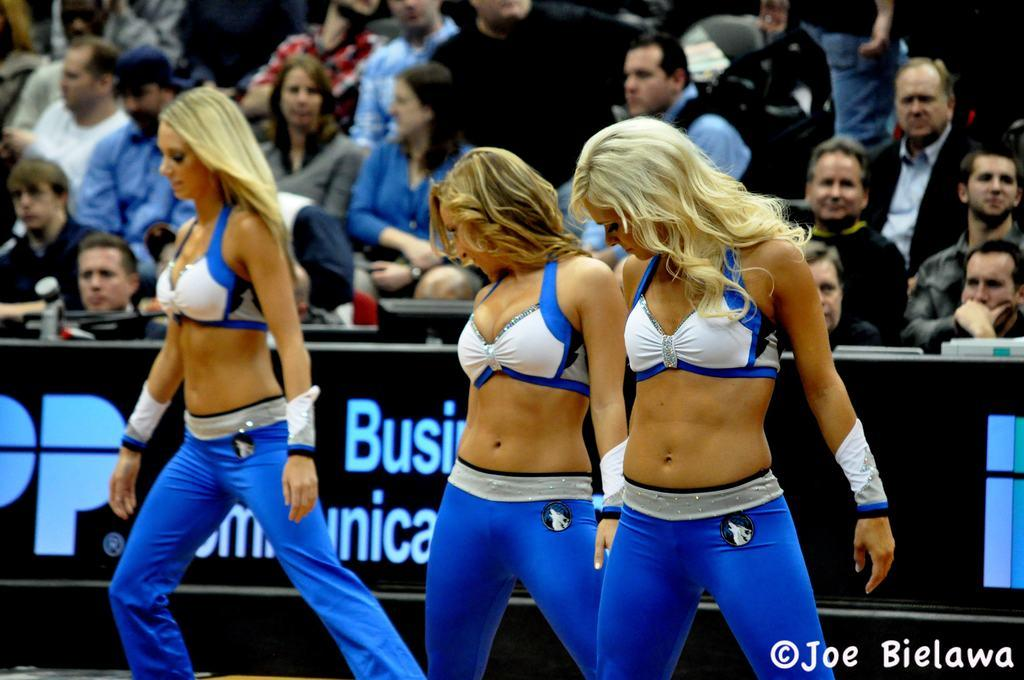Provide a one-sentence caption for the provided image. Joe Bielawa snapped a photo of three dances wearing blue and white uniforms. 